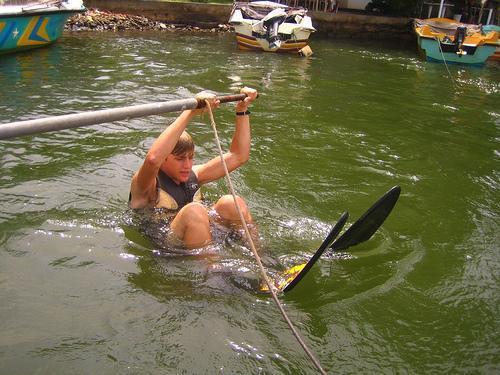How many skis does he have on?
Give a very brief answer. 2. How many boats are there?
Give a very brief answer. 3. How many chairs are there?
Give a very brief answer. 0. 